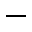Convert formula to latex. <formula><loc_0><loc_0><loc_500><loc_500>-</formula> 